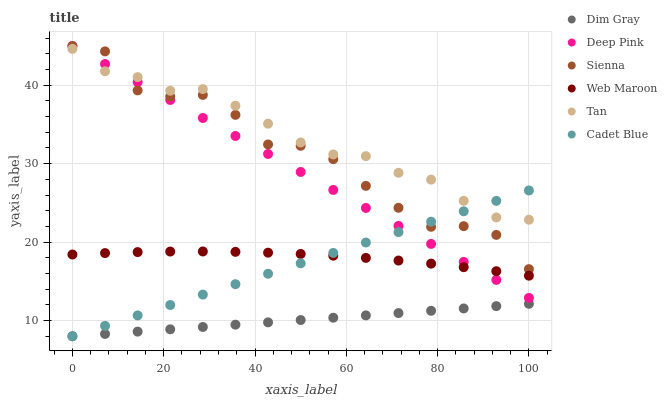Does Dim Gray have the minimum area under the curve?
Answer yes or no. Yes. Does Tan have the maximum area under the curve?
Answer yes or no. Yes. Does Web Maroon have the minimum area under the curve?
Answer yes or no. No. Does Web Maroon have the maximum area under the curve?
Answer yes or no. No. Is Dim Gray the smoothest?
Answer yes or no. Yes. Is Sienna the roughest?
Answer yes or no. Yes. Is Web Maroon the smoothest?
Answer yes or no. No. Is Web Maroon the roughest?
Answer yes or no. No. Does Cadet Blue have the lowest value?
Answer yes or no. Yes. Does Web Maroon have the lowest value?
Answer yes or no. No. Does Deep Pink have the highest value?
Answer yes or no. Yes. Does Web Maroon have the highest value?
Answer yes or no. No. Is Dim Gray less than Sienna?
Answer yes or no. Yes. Is Sienna greater than Web Maroon?
Answer yes or no. Yes. Does Sienna intersect Tan?
Answer yes or no. Yes. Is Sienna less than Tan?
Answer yes or no. No. Is Sienna greater than Tan?
Answer yes or no. No. Does Dim Gray intersect Sienna?
Answer yes or no. No. 